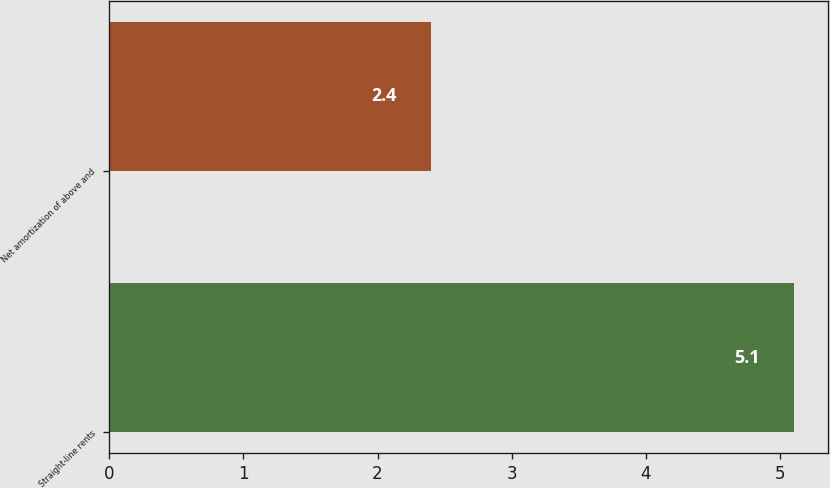<chart> <loc_0><loc_0><loc_500><loc_500><bar_chart><fcel>Straight-line rents<fcel>Net amortization of above and<nl><fcel>5.1<fcel>2.4<nl></chart> 